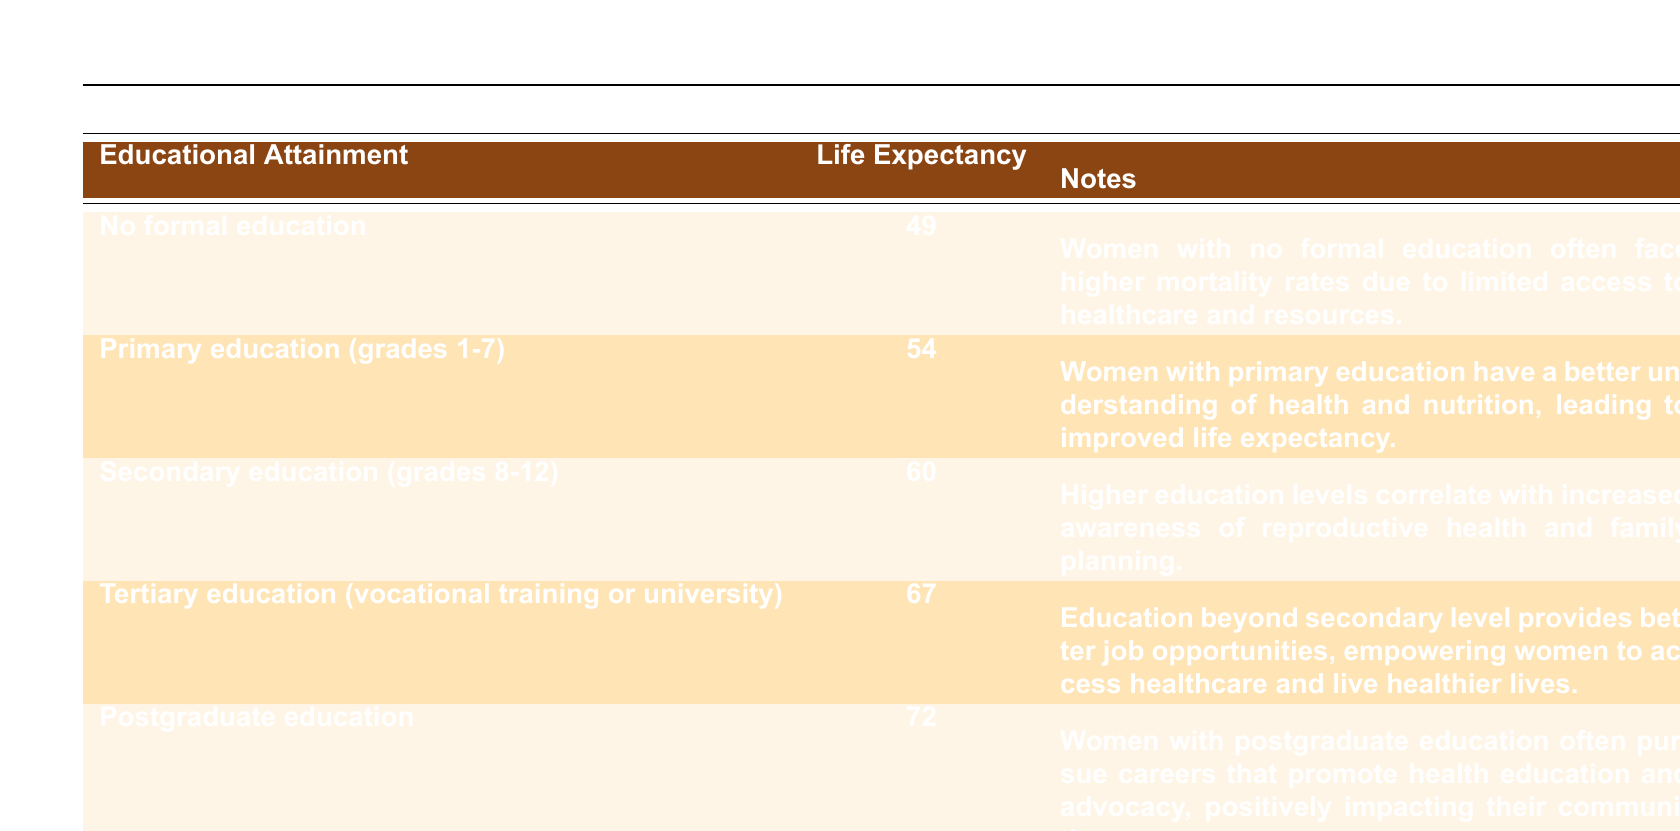What is the life expectancy for women with tertiary education? The table shows that women with tertiary education have an average life expectancy of 67 years, as stated in the corresponding row.
Answer: 67 How much higher is the life expectancy of women with postgraduate education compared to those with no formal education? Women with postgraduate education have a life expectancy of 72 years, while those with no formal education have a life expectancy of 49 years. The difference is calculated as 72 - 49 = 23 years.
Answer: 23 Is it true that women with secondary education have a higher life expectancy than those with primary education? According to the table, women with secondary education have a life expectancy of 60 years, and those with primary education have an average of 54 years. Since 60 is greater than 54, the statement is true.
Answer: Yes What is the average life expectancy of women across all educational attainment groups listed in the table? To find the average, we need to sum the life expectancies (49 + 54 + 60 + 67 + 72) = 302 and then divide by the number of groups (5). Thus, the average life expectancy is 302 / 5 = 60.4.
Answer: 60.4 How does the average life expectancy change as women attain higher levels of education? The table shows a trend where life expectancy increases with each level of educational attainment: 49 (no formal education), 54 (primary), 60 (secondary), 67 (tertiary), and 72 (postgraduate). This indicates a positive correlation between education and life expectancy.
Answer: Increases What is the life expectancy gap between women with primary education and those with tertiary education? Women with primary education live an average of 54 years, while those with tertiary education have a life expectancy of 67 years. The gap is found by subtracting 54 from 67, which gives us 67 - 54 = 13 years.
Answer: 13 Why are women with no formal education at a higher risk of lower life expectancy? The notes associated with the "no formal education" category explain that women in this group often encounter higher mortality rates due to limited access to healthcare and resources.
Answer: Limited access to healthcare and resources What is the significance of postgraduate education regarding women's health education and advocacy? The table notes that women with postgraduate education frequently pursue careers promoting health education and advocacy. This suggests that their education level enables them to positively impact their communities' health awareness and access to resources.
Answer: Positive impact on communities 